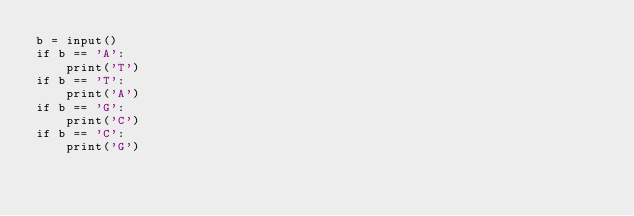Convert code to text. <code><loc_0><loc_0><loc_500><loc_500><_Python_>b = input()
if b == 'A':
    print('T')
if b == 'T':
    print('A')
if b == 'G':
    print('C')
if b == 'C':
    print('G')</code> 